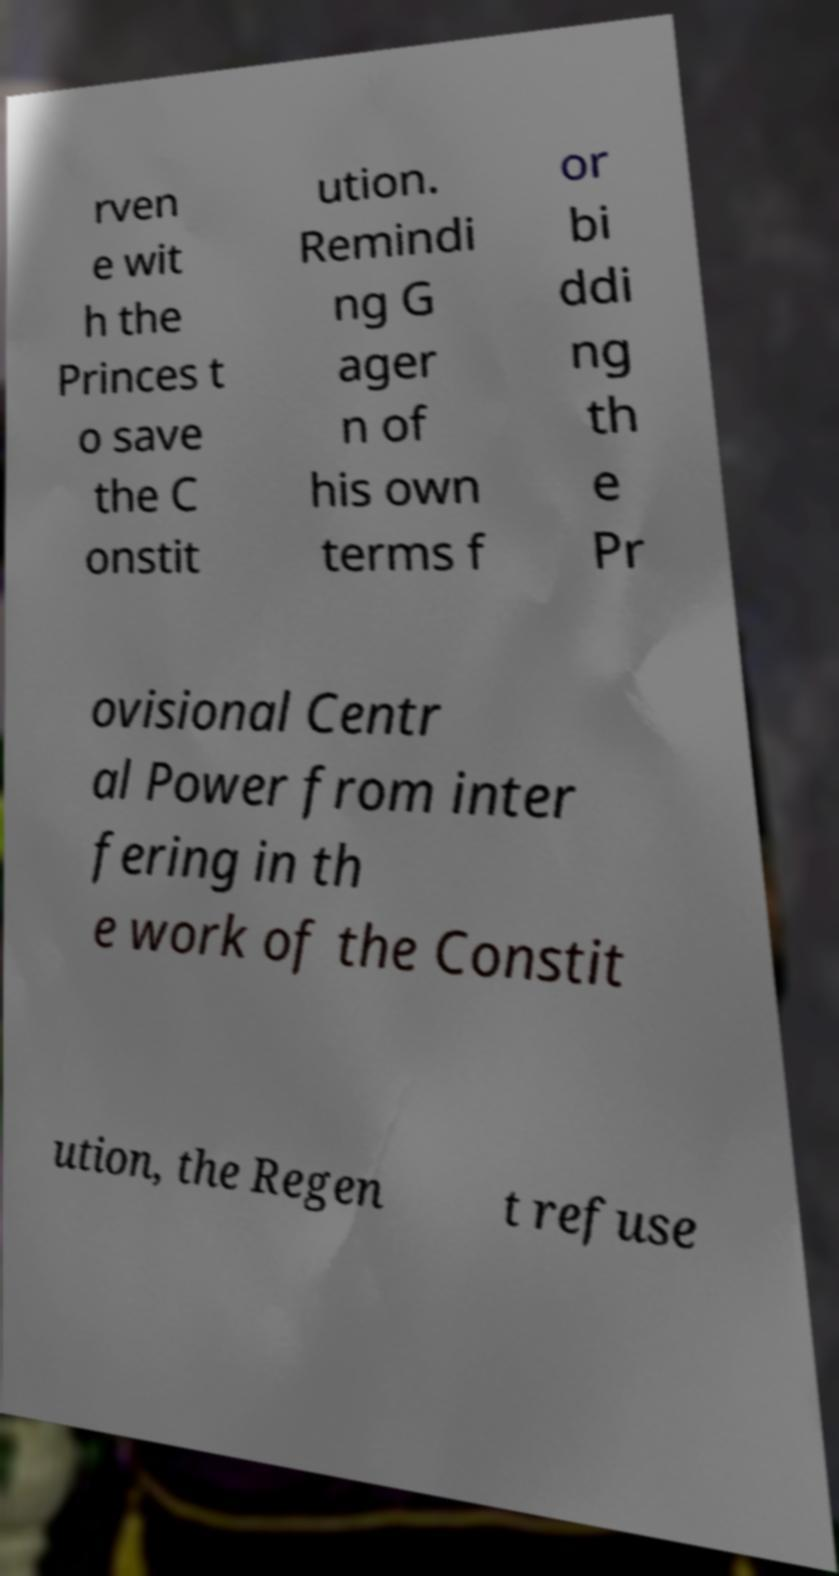Could you assist in decoding the text presented in this image and type it out clearly? rven e wit h the Princes t o save the C onstit ution. Remindi ng G ager n of his own terms f or bi ddi ng th e Pr ovisional Centr al Power from inter fering in th e work of the Constit ution, the Regen t refuse 